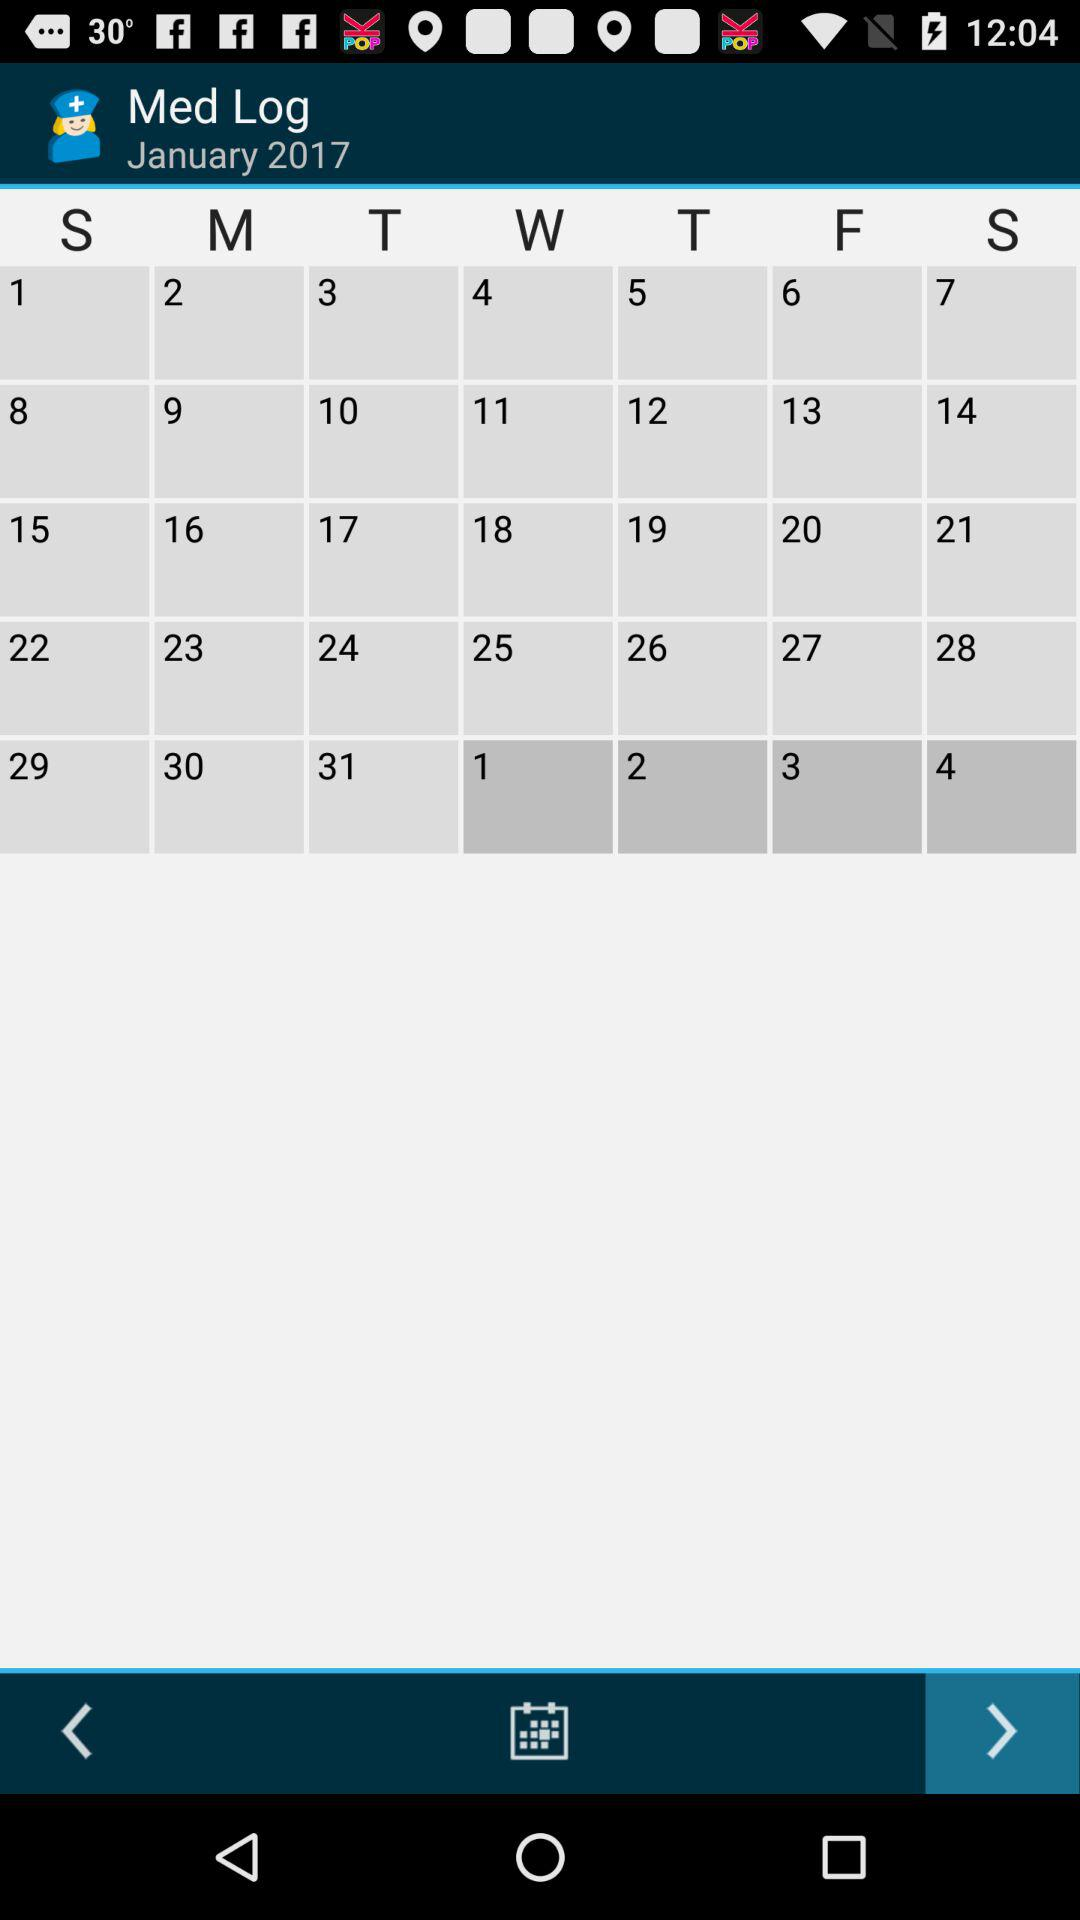What month and year is it on the calendar? The month and year on the calendar are January and 2017. 